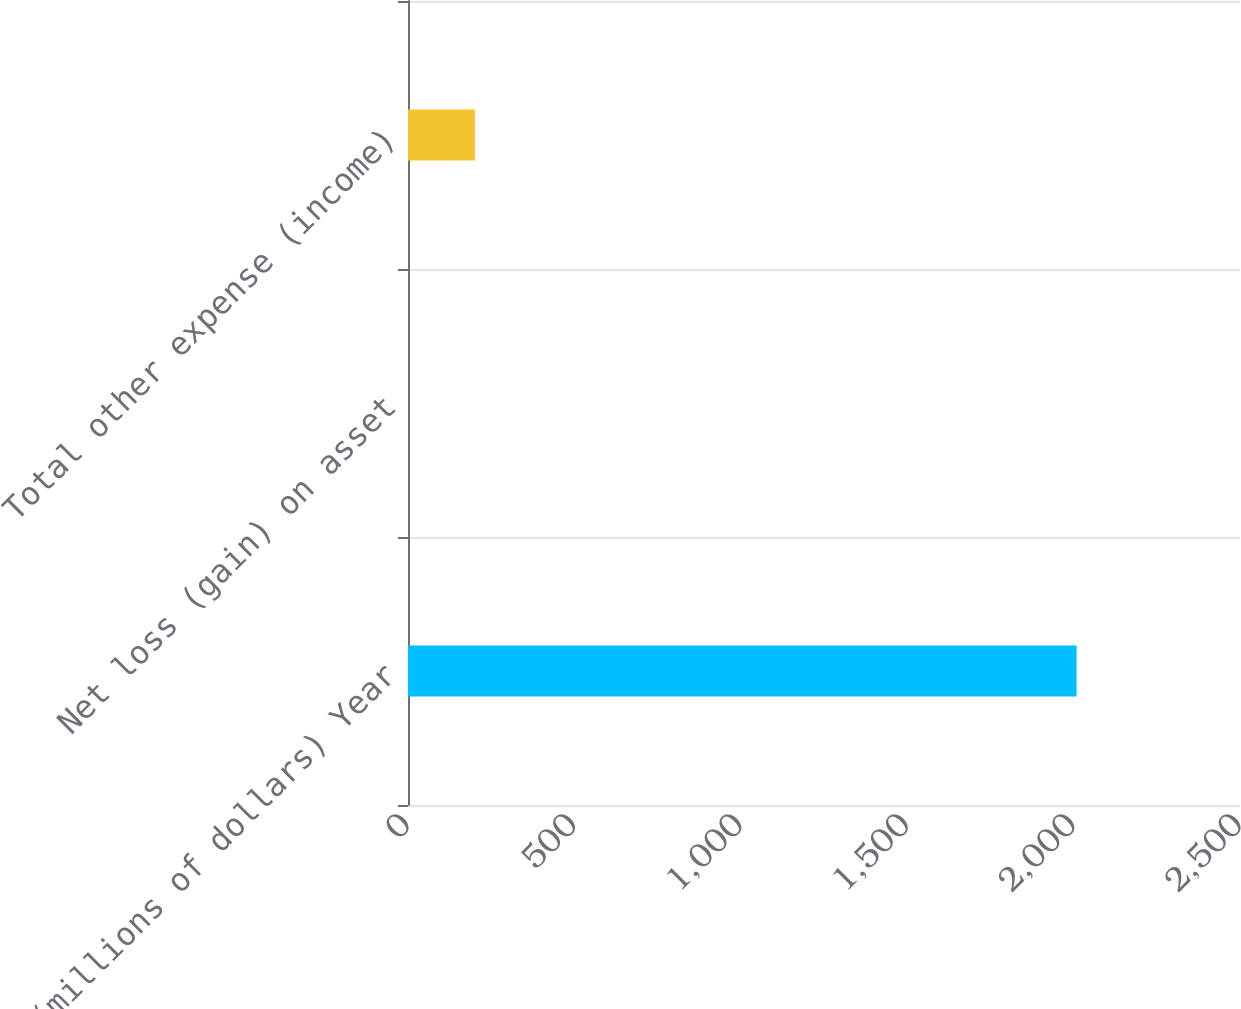<chart> <loc_0><loc_0><loc_500><loc_500><bar_chart><fcel>(millions of dollars) Year<fcel>Net loss (gain) on asset<fcel>Total other expense (income)<nl><fcel>2009<fcel>0.1<fcel>200.99<nl></chart> 